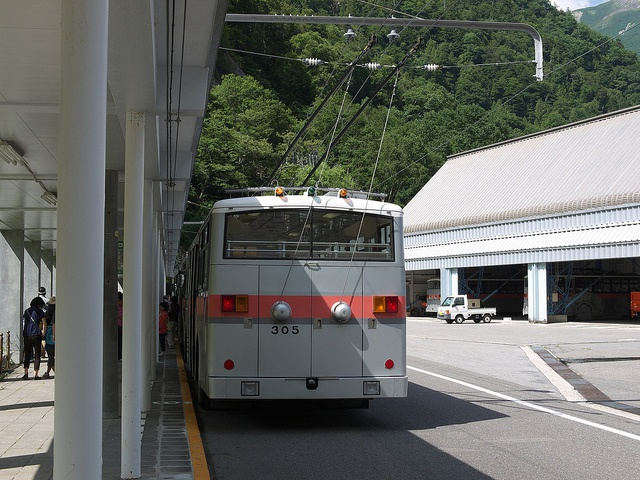Describe the objects in this image and their specific colors. I can see bus in gray, black, and maroon tones, people in gray, black, and darkgray tones, truck in gray, lightgray, black, and darkgray tones, people in gray, black, blue, and darkblue tones, and people in gray, black, and maroon tones in this image. 